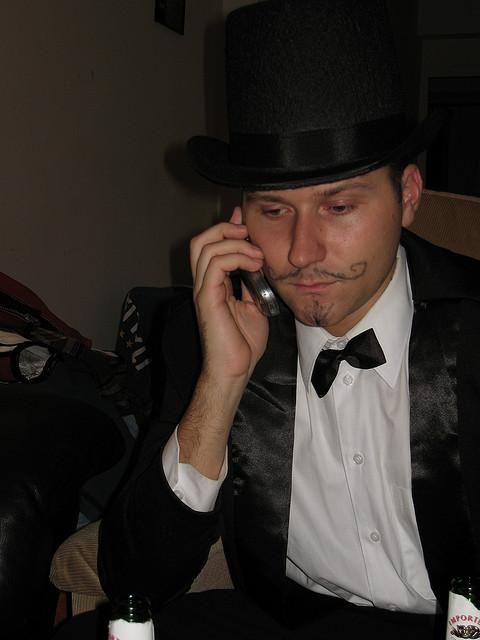What kind of phone is he using?

Choices:
A) rotary
B) landline
C) cellular
D) pay cellular 